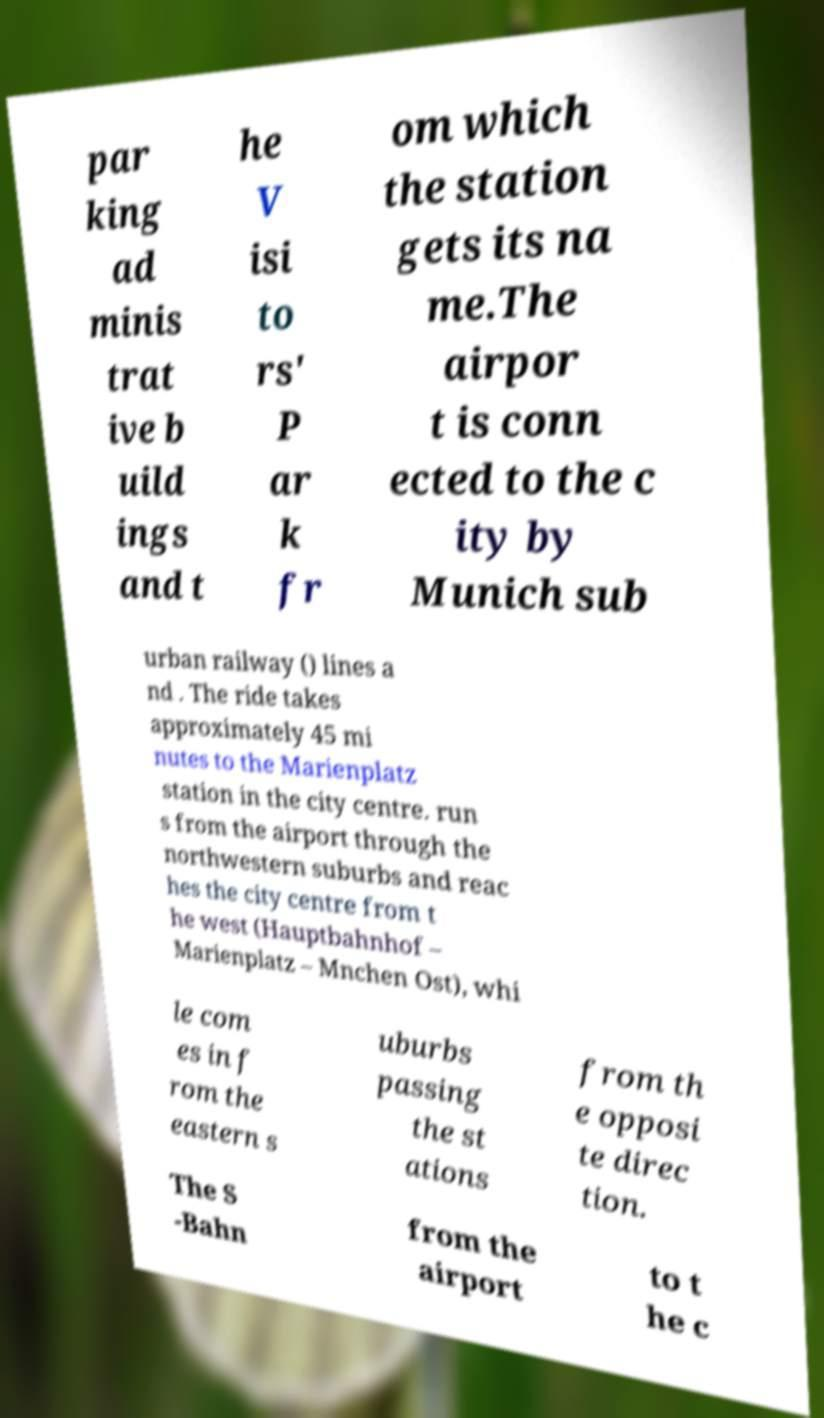Please read and relay the text visible in this image. What does it say? par king ad minis trat ive b uild ings and t he V isi to rs' P ar k fr om which the station gets its na me.The airpor t is conn ected to the c ity by Munich sub urban railway () lines a nd . The ride takes approximately 45 mi nutes to the Marienplatz station in the city centre. run s from the airport through the northwestern suburbs and reac hes the city centre from t he west (Hauptbahnhof – Marienplatz – Mnchen Ost), whi le com es in f rom the eastern s uburbs passing the st ations from th e opposi te direc tion. The S -Bahn from the airport to t he c 